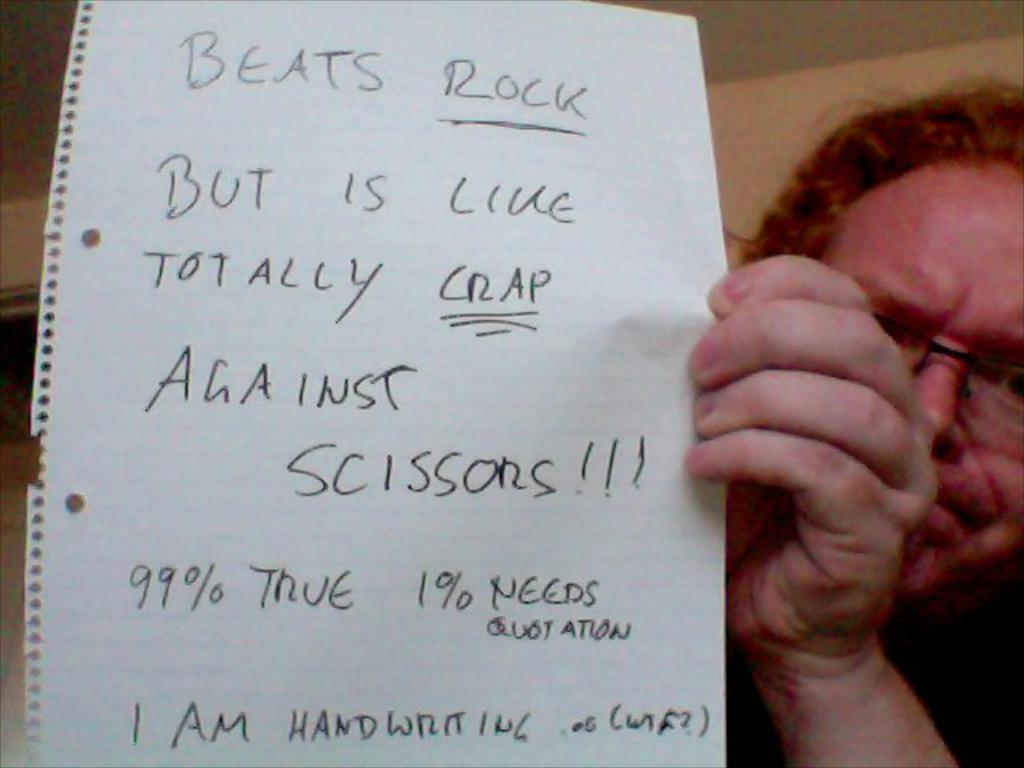Please provide a concise description of this image. In this image we can see a man is holding a paper in the hand and something written on it. 